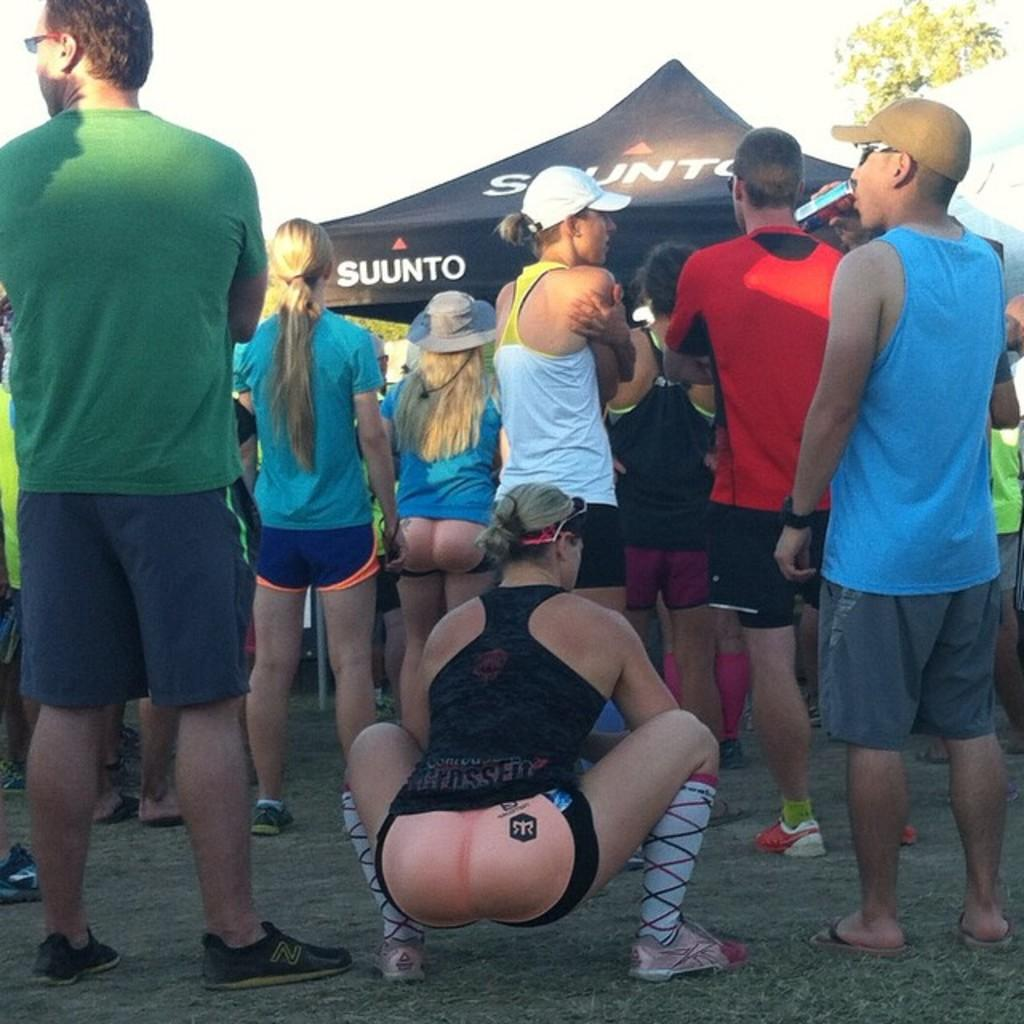<image>
Share a concise interpretation of the image provided. A crowd of people, including someone wearing a fake joke butt, are gathered in front of a Suunto tent. 